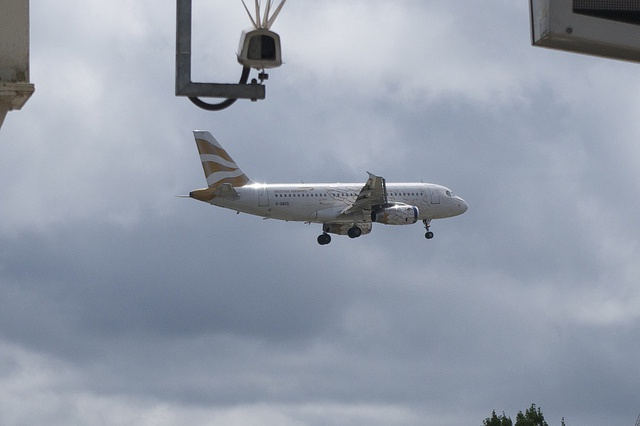Describe the objects in this image and their specific colors. I can see a airplane in gray, darkgray, and black tones in this image. 